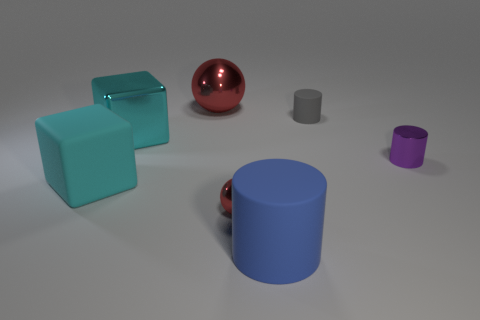What is the shape of the red metallic object behind the tiny red metallic ball?
Provide a succinct answer. Sphere. Are there fewer big matte cylinders than red shiny spheres?
Offer a very short reply. Yes. There is a red sphere left of the red ball in front of the large ball; is there a big red shiny sphere that is behind it?
Make the answer very short. No. What number of rubber objects are either small cylinders or big blue objects?
Offer a terse response. 2. Is the color of the small sphere the same as the large sphere?
Give a very brief answer. Yes. There is a tiny red metal object; what number of large balls are in front of it?
Your answer should be very brief. 0. How many big objects are both in front of the large shiny sphere and behind the cyan rubber object?
Offer a very short reply. 1. There is a big cyan object that is the same material as the tiny purple cylinder; what is its shape?
Provide a short and direct response. Cube. There is a red object in front of the tiny purple object; is it the same size as the cylinder that is in front of the small red ball?
Your answer should be compact. No. There is a matte thing that is on the left side of the big rubber cylinder; what is its color?
Make the answer very short. Cyan. 